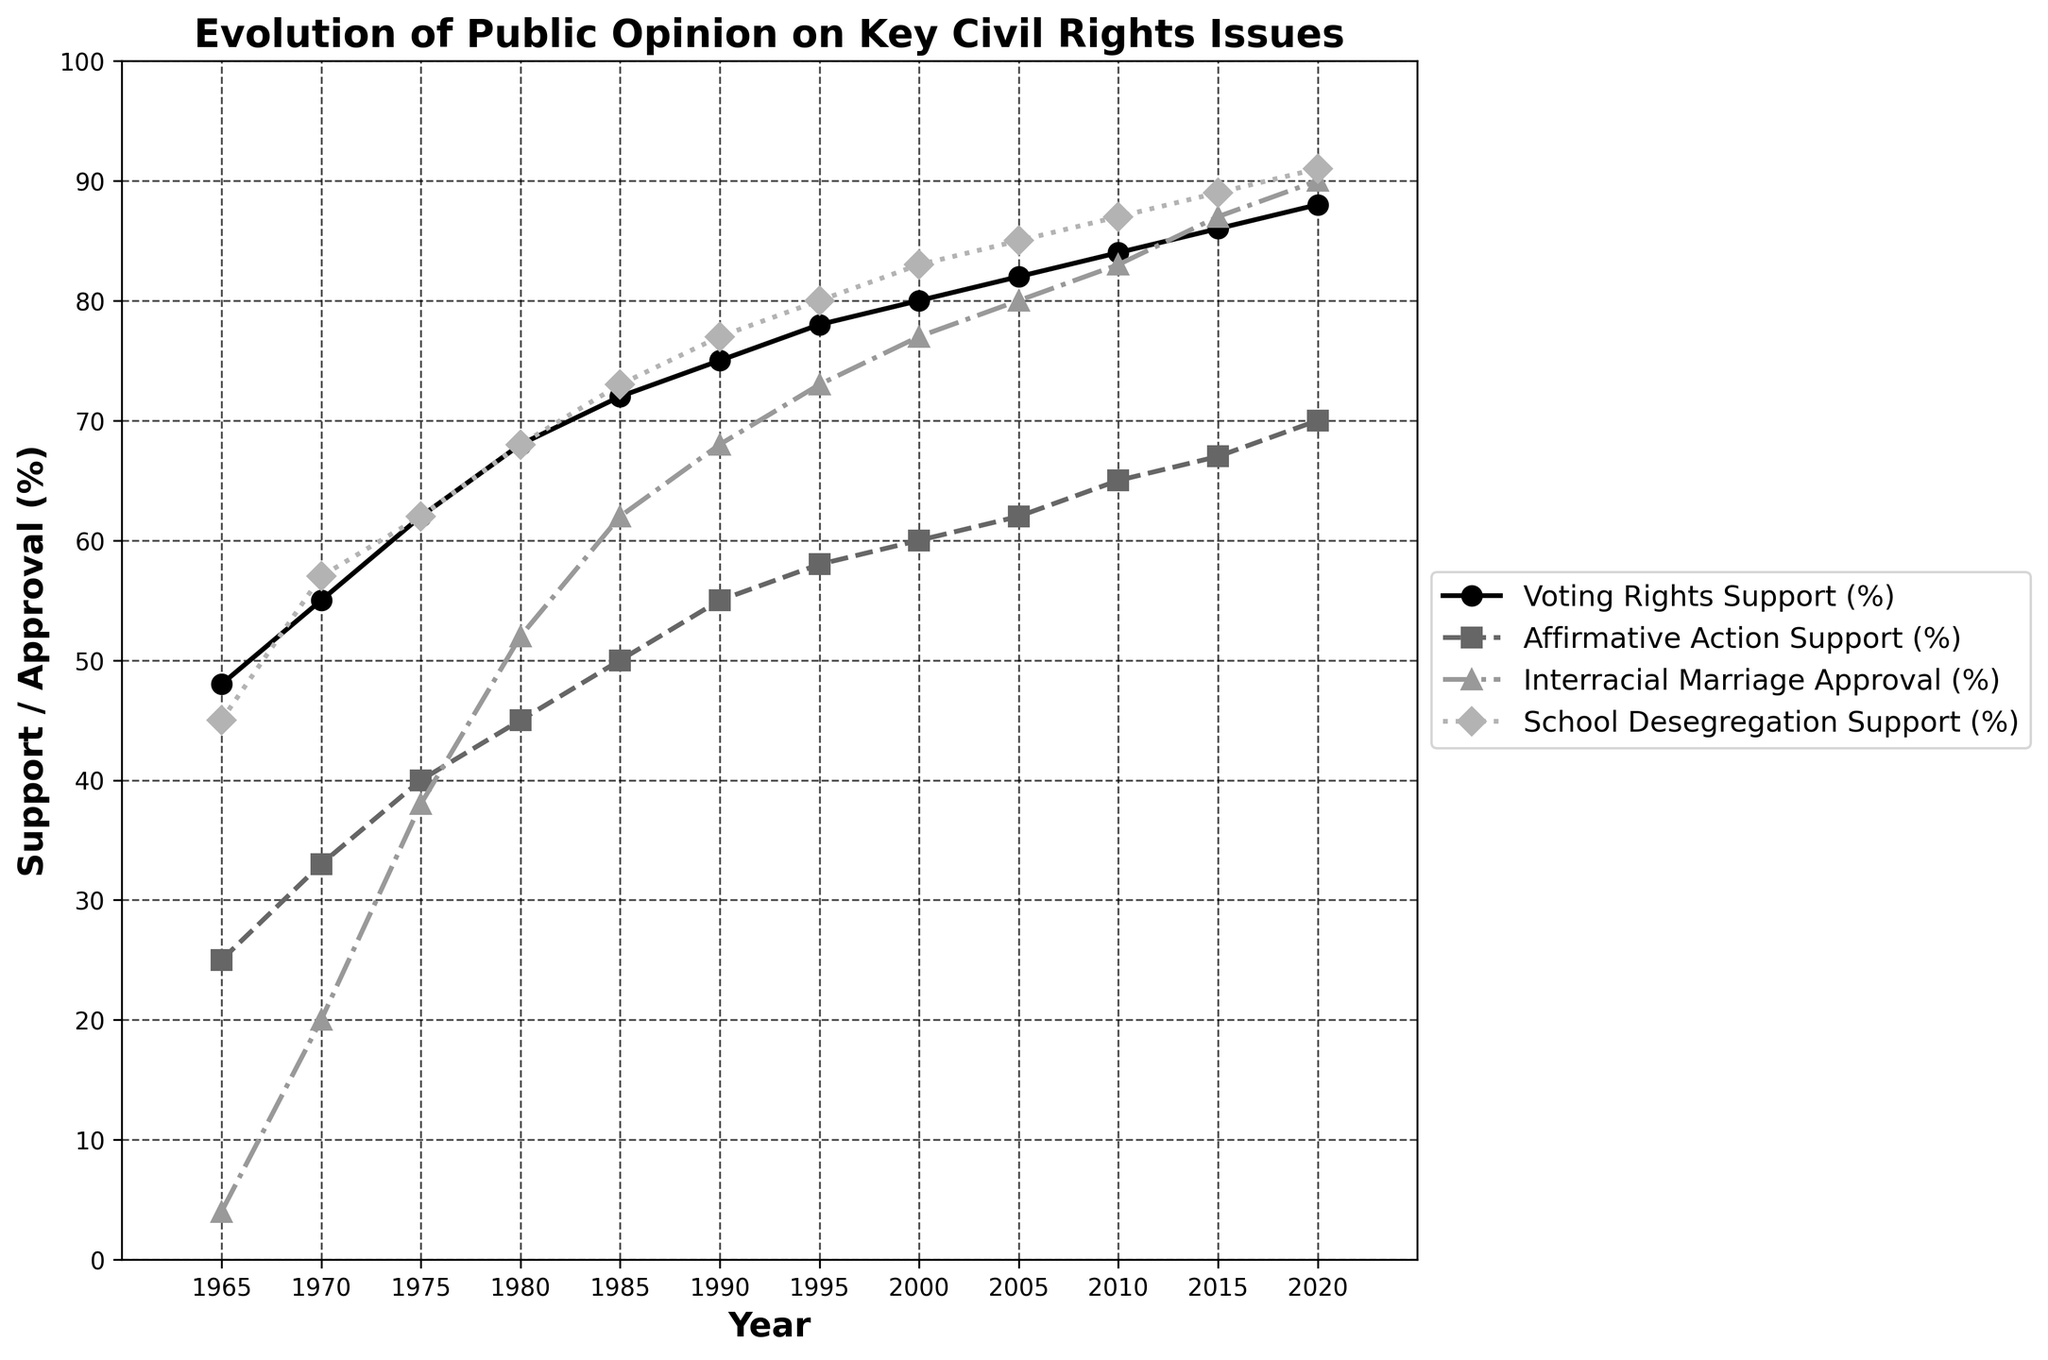Which year shows the greatest increase in Voting Rights Support (%) compared to the previous year? The greatest increase is identified by comparing each year's Voting Rights Support (%) to the previous year's value. The largest increase is calculated by identifying the most significant difference between two consecutive years.
Answer: 1965 to 1970, 7% What is the average support for Affirmative Action (%) from 1980 to 2020? To find the average, sum the support values from 1980, 1985, 1990, 1995, 2000, 2005, 2010, 2015, and 2020, and divide by the number of years (9). The values are: 45, 50, 55, 58, 60, 62, 65, 67, and 70. The sum is 532, and the average is found by dividing 532 by 9.
Answer: 59.11% Which civil rights issue has the greatest support increase per decade on average from 1965 to 2020? For each civil rights issue, the change per decade is calculated by subtracting the initial value in 1965 from the final value in 2020, then dividing by the number of decades (5.5). Voting Rights: (88-48)/5.5; Affirmative Action: (70-25)/5.5; Interracial Marriage: (90-4)/5.5; School Desegregation: (91-45)/5.5.
Answer: Interracial Marriage, 15.64% per decade What is the trend difference between support for Voting Rights and Affirmative Action from 1980 to 2000? The trend difference is identified by subtracting the Affirmative Action support percentage from the Voting Rights support percentage for each year from 1980 to 2000 and analyzing these differences: 68-45, 72-50, 75-55, 78-58, 80-60. The differences are 23, 22, 20, 20, 20.
Answer: The trend shows a consistent difference of around 20-23% At what year was the support for School Desegregation greater than 80%? The support for School Desegregation (%) needs to be identified visually for when it first exceeds the 80% mark. In 2000, it reaches 83%.
Answer: 2000 